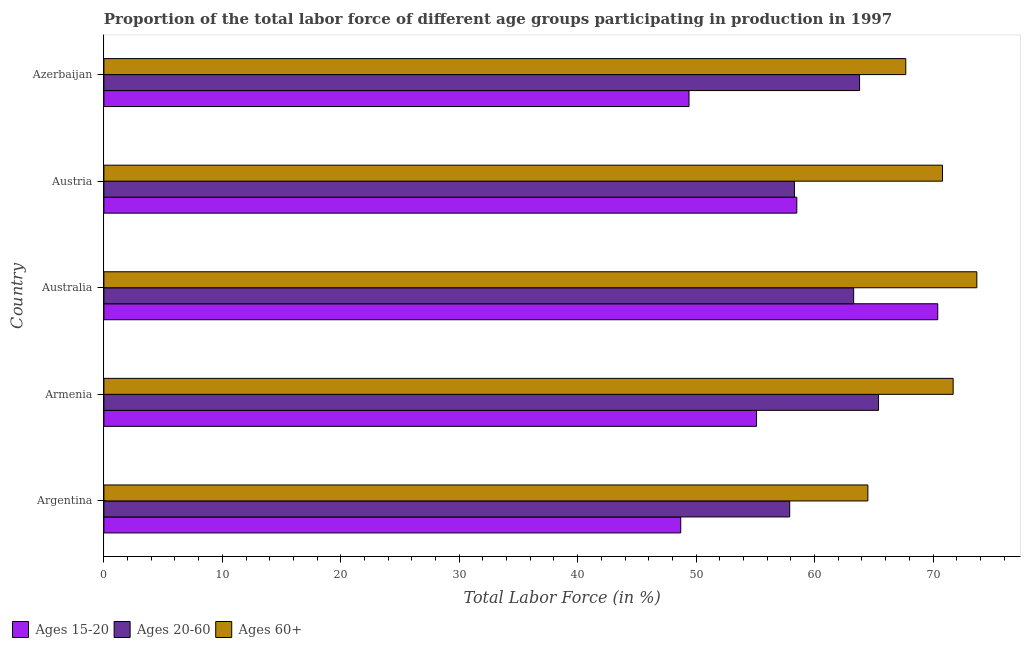How many different coloured bars are there?
Keep it short and to the point. 3. How many groups of bars are there?
Your answer should be compact. 5. Are the number of bars per tick equal to the number of legend labels?
Ensure brevity in your answer.  Yes. How many bars are there on the 1st tick from the bottom?
Ensure brevity in your answer.  3. What is the label of the 5th group of bars from the top?
Make the answer very short. Argentina. In how many cases, is the number of bars for a given country not equal to the number of legend labels?
Ensure brevity in your answer.  0. What is the percentage of labor force within the age group 20-60 in Australia?
Your answer should be compact. 63.3. Across all countries, what is the maximum percentage of labor force within the age group 15-20?
Your answer should be very brief. 70.4. Across all countries, what is the minimum percentage of labor force above age 60?
Keep it short and to the point. 64.5. What is the total percentage of labor force within the age group 20-60 in the graph?
Provide a succinct answer. 308.7. What is the difference between the percentage of labor force within the age group 20-60 in Armenia and that in Azerbaijan?
Make the answer very short. 1.6. What is the difference between the percentage of labor force above age 60 in Argentina and the percentage of labor force within the age group 20-60 in Azerbaijan?
Give a very brief answer. 0.7. What is the average percentage of labor force above age 60 per country?
Your answer should be very brief. 69.68. What is the difference between the percentage of labor force within the age group 15-20 and percentage of labor force above age 60 in Argentina?
Provide a short and direct response. -15.8. In how many countries, is the percentage of labor force within the age group 20-60 greater than 12 %?
Provide a short and direct response. 5. What is the ratio of the percentage of labor force above age 60 in Austria to that in Azerbaijan?
Offer a very short reply. 1.05. Is the difference between the percentage of labor force within the age group 20-60 in Austria and Azerbaijan greater than the difference between the percentage of labor force above age 60 in Austria and Azerbaijan?
Your answer should be very brief. No. What is the difference between the highest and the second highest percentage of labor force within the age group 15-20?
Offer a very short reply. 11.9. What is the difference between the highest and the lowest percentage of labor force within the age group 15-20?
Offer a very short reply. 21.7. What does the 3rd bar from the top in Austria represents?
Give a very brief answer. Ages 15-20. What does the 2nd bar from the bottom in Austria represents?
Your answer should be very brief. Ages 20-60. Is it the case that in every country, the sum of the percentage of labor force within the age group 15-20 and percentage of labor force within the age group 20-60 is greater than the percentage of labor force above age 60?
Your answer should be compact. Yes. What is the difference between two consecutive major ticks on the X-axis?
Ensure brevity in your answer.  10. Are the values on the major ticks of X-axis written in scientific E-notation?
Your response must be concise. No. Does the graph contain grids?
Offer a terse response. No. What is the title of the graph?
Provide a succinct answer. Proportion of the total labor force of different age groups participating in production in 1997. What is the label or title of the X-axis?
Provide a short and direct response. Total Labor Force (in %). What is the label or title of the Y-axis?
Offer a very short reply. Country. What is the Total Labor Force (in %) of Ages 15-20 in Argentina?
Provide a succinct answer. 48.7. What is the Total Labor Force (in %) in Ages 20-60 in Argentina?
Provide a succinct answer. 57.9. What is the Total Labor Force (in %) of Ages 60+ in Argentina?
Provide a succinct answer. 64.5. What is the Total Labor Force (in %) of Ages 15-20 in Armenia?
Make the answer very short. 55.1. What is the Total Labor Force (in %) in Ages 20-60 in Armenia?
Make the answer very short. 65.4. What is the Total Labor Force (in %) of Ages 60+ in Armenia?
Make the answer very short. 71.7. What is the Total Labor Force (in %) of Ages 15-20 in Australia?
Your answer should be compact. 70.4. What is the Total Labor Force (in %) of Ages 20-60 in Australia?
Ensure brevity in your answer.  63.3. What is the Total Labor Force (in %) in Ages 60+ in Australia?
Provide a short and direct response. 73.7. What is the Total Labor Force (in %) in Ages 15-20 in Austria?
Provide a short and direct response. 58.5. What is the Total Labor Force (in %) in Ages 20-60 in Austria?
Offer a terse response. 58.3. What is the Total Labor Force (in %) of Ages 60+ in Austria?
Your answer should be compact. 70.8. What is the Total Labor Force (in %) of Ages 15-20 in Azerbaijan?
Your answer should be very brief. 49.4. What is the Total Labor Force (in %) in Ages 20-60 in Azerbaijan?
Give a very brief answer. 63.8. What is the Total Labor Force (in %) in Ages 60+ in Azerbaijan?
Provide a succinct answer. 67.7. Across all countries, what is the maximum Total Labor Force (in %) in Ages 15-20?
Ensure brevity in your answer.  70.4. Across all countries, what is the maximum Total Labor Force (in %) of Ages 20-60?
Your response must be concise. 65.4. Across all countries, what is the maximum Total Labor Force (in %) in Ages 60+?
Keep it short and to the point. 73.7. Across all countries, what is the minimum Total Labor Force (in %) in Ages 15-20?
Ensure brevity in your answer.  48.7. Across all countries, what is the minimum Total Labor Force (in %) of Ages 20-60?
Offer a terse response. 57.9. Across all countries, what is the minimum Total Labor Force (in %) of Ages 60+?
Keep it short and to the point. 64.5. What is the total Total Labor Force (in %) of Ages 15-20 in the graph?
Your response must be concise. 282.1. What is the total Total Labor Force (in %) of Ages 20-60 in the graph?
Your answer should be compact. 308.7. What is the total Total Labor Force (in %) in Ages 60+ in the graph?
Ensure brevity in your answer.  348.4. What is the difference between the Total Labor Force (in %) of Ages 15-20 in Argentina and that in Armenia?
Keep it short and to the point. -6.4. What is the difference between the Total Labor Force (in %) of Ages 60+ in Argentina and that in Armenia?
Your response must be concise. -7.2. What is the difference between the Total Labor Force (in %) of Ages 15-20 in Argentina and that in Australia?
Ensure brevity in your answer.  -21.7. What is the difference between the Total Labor Force (in %) in Ages 20-60 in Argentina and that in Australia?
Give a very brief answer. -5.4. What is the difference between the Total Labor Force (in %) in Ages 60+ in Argentina and that in Australia?
Offer a terse response. -9.2. What is the difference between the Total Labor Force (in %) in Ages 15-20 in Argentina and that in Austria?
Offer a terse response. -9.8. What is the difference between the Total Labor Force (in %) in Ages 20-60 in Argentina and that in Austria?
Make the answer very short. -0.4. What is the difference between the Total Labor Force (in %) in Ages 15-20 in Argentina and that in Azerbaijan?
Offer a terse response. -0.7. What is the difference between the Total Labor Force (in %) of Ages 15-20 in Armenia and that in Australia?
Keep it short and to the point. -15.3. What is the difference between the Total Labor Force (in %) in Ages 20-60 in Armenia and that in Austria?
Offer a terse response. 7.1. What is the difference between the Total Labor Force (in %) of Ages 60+ in Armenia and that in Austria?
Provide a succinct answer. 0.9. What is the difference between the Total Labor Force (in %) in Ages 20-60 in Armenia and that in Azerbaijan?
Give a very brief answer. 1.6. What is the difference between the Total Labor Force (in %) of Ages 60+ in Armenia and that in Azerbaijan?
Keep it short and to the point. 4. What is the difference between the Total Labor Force (in %) of Ages 15-20 in Australia and that in Azerbaijan?
Your answer should be very brief. 21. What is the difference between the Total Labor Force (in %) of Ages 60+ in Australia and that in Azerbaijan?
Provide a short and direct response. 6. What is the difference between the Total Labor Force (in %) of Ages 20-60 in Austria and that in Azerbaijan?
Provide a short and direct response. -5.5. What is the difference between the Total Labor Force (in %) in Ages 15-20 in Argentina and the Total Labor Force (in %) in Ages 20-60 in Armenia?
Your answer should be compact. -16.7. What is the difference between the Total Labor Force (in %) in Ages 20-60 in Argentina and the Total Labor Force (in %) in Ages 60+ in Armenia?
Provide a succinct answer. -13.8. What is the difference between the Total Labor Force (in %) of Ages 15-20 in Argentina and the Total Labor Force (in %) of Ages 20-60 in Australia?
Make the answer very short. -14.6. What is the difference between the Total Labor Force (in %) in Ages 15-20 in Argentina and the Total Labor Force (in %) in Ages 60+ in Australia?
Keep it short and to the point. -25. What is the difference between the Total Labor Force (in %) in Ages 20-60 in Argentina and the Total Labor Force (in %) in Ages 60+ in Australia?
Your answer should be very brief. -15.8. What is the difference between the Total Labor Force (in %) of Ages 15-20 in Argentina and the Total Labor Force (in %) of Ages 60+ in Austria?
Your answer should be compact. -22.1. What is the difference between the Total Labor Force (in %) in Ages 20-60 in Argentina and the Total Labor Force (in %) in Ages 60+ in Austria?
Provide a succinct answer. -12.9. What is the difference between the Total Labor Force (in %) of Ages 15-20 in Argentina and the Total Labor Force (in %) of Ages 20-60 in Azerbaijan?
Provide a succinct answer. -15.1. What is the difference between the Total Labor Force (in %) in Ages 15-20 in Armenia and the Total Labor Force (in %) in Ages 20-60 in Australia?
Your response must be concise. -8.2. What is the difference between the Total Labor Force (in %) of Ages 15-20 in Armenia and the Total Labor Force (in %) of Ages 60+ in Australia?
Ensure brevity in your answer.  -18.6. What is the difference between the Total Labor Force (in %) of Ages 15-20 in Armenia and the Total Labor Force (in %) of Ages 60+ in Austria?
Ensure brevity in your answer.  -15.7. What is the difference between the Total Labor Force (in %) in Ages 15-20 in Armenia and the Total Labor Force (in %) in Ages 20-60 in Azerbaijan?
Keep it short and to the point. -8.7. What is the difference between the Total Labor Force (in %) of Ages 15-20 in Australia and the Total Labor Force (in %) of Ages 20-60 in Austria?
Make the answer very short. 12.1. What is the difference between the Total Labor Force (in %) of Ages 15-20 in Australia and the Total Labor Force (in %) of Ages 60+ in Austria?
Your answer should be very brief. -0.4. What is the difference between the Total Labor Force (in %) of Ages 15-20 in Australia and the Total Labor Force (in %) of Ages 20-60 in Azerbaijan?
Make the answer very short. 6.6. What is the difference between the Total Labor Force (in %) of Ages 15-20 in Australia and the Total Labor Force (in %) of Ages 60+ in Azerbaijan?
Your answer should be compact. 2.7. What is the difference between the Total Labor Force (in %) in Ages 20-60 in Australia and the Total Labor Force (in %) in Ages 60+ in Azerbaijan?
Provide a succinct answer. -4.4. What is the difference between the Total Labor Force (in %) of Ages 15-20 in Austria and the Total Labor Force (in %) of Ages 60+ in Azerbaijan?
Your answer should be compact. -9.2. What is the difference between the Total Labor Force (in %) of Ages 20-60 in Austria and the Total Labor Force (in %) of Ages 60+ in Azerbaijan?
Ensure brevity in your answer.  -9.4. What is the average Total Labor Force (in %) of Ages 15-20 per country?
Provide a short and direct response. 56.42. What is the average Total Labor Force (in %) of Ages 20-60 per country?
Your answer should be very brief. 61.74. What is the average Total Labor Force (in %) of Ages 60+ per country?
Offer a very short reply. 69.68. What is the difference between the Total Labor Force (in %) of Ages 15-20 and Total Labor Force (in %) of Ages 60+ in Argentina?
Keep it short and to the point. -15.8. What is the difference between the Total Labor Force (in %) of Ages 15-20 and Total Labor Force (in %) of Ages 60+ in Armenia?
Keep it short and to the point. -16.6. What is the difference between the Total Labor Force (in %) in Ages 20-60 and Total Labor Force (in %) in Ages 60+ in Armenia?
Make the answer very short. -6.3. What is the difference between the Total Labor Force (in %) in Ages 15-20 and Total Labor Force (in %) in Ages 20-60 in Australia?
Offer a terse response. 7.1. What is the difference between the Total Labor Force (in %) of Ages 20-60 and Total Labor Force (in %) of Ages 60+ in Australia?
Make the answer very short. -10.4. What is the difference between the Total Labor Force (in %) of Ages 15-20 and Total Labor Force (in %) of Ages 60+ in Austria?
Your response must be concise. -12.3. What is the difference between the Total Labor Force (in %) in Ages 15-20 and Total Labor Force (in %) in Ages 20-60 in Azerbaijan?
Provide a succinct answer. -14.4. What is the difference between the Total Labor Force (in %) of Ages 15-20 and Total Labor Force (in %) of Ages 60+ in Azerbaijan?
Your answer should be compact. -18.3. What is the difference between the Total Labor Force (in %) of Ages 20-60 and Total Labor Force (in %) of Ages 60+ in Azerbaijan?
Your answer should be compact. -3.9. What is the ratio of the Total Labor Force (in %) in Ages 15-20 in Argentina to that in Armenia?
Your answer should be compact. 0.88. What is the ratio of the Total Labor Force (in %) in Ages 20-60 in Argentina to that in Armenia?
Offer a terse response. 0.89. What is the ratio of the Total Labor Force (in %) of Ages 60+ in Argentina to that in Armenia?
Keep it short and to the point. 0.9. What is the ratio of the Total Labor Force (in %) of Ages 15-20 in Argentina to that in Australia?
Your answer should be very brief. 0.69. What is the ratio of the Total Labor Force (in %) in Ages 20-60 in Argentina to that in Australia?
Offer a very short reply. 0.91. What is the ratio of the Total Labor Force (in %) of Ages 60+ in Argentina to that in Australia?
Offer a terse response. 0.88. What is the ratio of the Total Labor Force (in %) of Ages 15-20 in Argentina to that in Austria?
Your response must be concise. 0.83. What is the ratio of the Total Labor Force (in %) in Ages 20-60 in Argentina to that in Austria?
Provide a short and direct response. 0.99. What is the ratio of the Total Labor Force (in %) of Ages 60+ in Argentina to that in Austria?
Keep it short and to the point. 0.91. What is the ratio of the Total Labor Force (in %) in Ages 15-20 in Argentina to that in Azerbaijan?
Offer a very short reply. 0.99. What is the ratio of the Total Labor Force (in %) in Ages 20-60 in Argentina to that in Azerbaijan?
Ensure brevity in your answer.  0.91. What is the ratio of the Total Labor Force (in %) in Ages 60+ in Argentina to that in Azerbaijan?
Make the answer very short. 0.95. What is the ratio of the Total Labor Force (in %) of Ages 15-20 in Armenia to that in Australia?
Provide a short and direct response. 0.78. What is the ratio of the Total Labor Force (in %) of Ages 20-60 in Armenia to that in Australia?
Provide a succinct answer. 1.03. What is the ratio of the Total Labor Force (in %) of Ages 60+ in Armenia to that in Australia?
Provide a short and direct response. 0.97. What is the ratio of the Total Labor Force (in %) in Ages 15-20 in Armenia to that in Austria?
Make the answer very short. 0.94. What is the ratio of the Total Labor Force (in %) in Ages 20-60 in Armenia to that in Austria?
Provide a succinct answer. 1.12. What is the ratio of the Total Labor Force (in %) in Ages 60+ in Armenia to that in Austria?
Your answer should be compact. 1.01. What is the ratio of the Total Labor Force (in %) of Ages 15-20 in Armenia to that in Azerbaijan?
Offer a very short reply. 1.12. What is the ratio of the Total Labor Force (in %) in Ages 20-60 in Armenia to that in Azerbaijan?
Keep it short and to the point. 1.03. What is the ratio of the Total Labor Force (in %) in Ages 60+ in Armenia to that in Azerbaijan?
Provide a short and direct response. 1.06. What is the ratio of the Total Labor Force (in %) of Ages 15-20 in Australia to that in Austria?
Your response must be concise. 1.2. What is the ratio of the Total Labor Force (in %) of Ages 20-60 in Australia to that in Austria?
Ensure brevity in your answer.  1.09. What is the ratio of the Total Labor Force (in %) of Ages 60+ in Australia to that in Austria?
Provide a succinct answer. 1.04. What is the ratio of the Total Labor Force (in %) in Ages 15-20 in Australia to that in Azerbaijan?
Offer a very short reply. 1.43. What is the ratio of the Total Labor Force (in %) of Ages 20-60 in Australia to that in Azerbaijan?
Provide a succinct answer. 0.99. What is the ratio of the Total Labor Force (in %) in Ages 60+ in Australia to that in Azerbaijan?
Provide a succinct answer. 1.09. What is the ratio of the Total Labor Force (in %) of Ages 15-20 in Austria to that in Azerbaijan?
Your answer should be compact. 1.18. What is the ratio of the Total Labor Force (in %) in Ages 20-60 in Austria to that in Azerbaijan?
Offer a very short reply. 0.91. What is the ratio of the Total Labor Force (in %) in Ages 60+ in Austria to that in Azerbaijan?
Make the answer very short. 1.05. What is the difference between the highest and the second highest Total Labor Force (in %) of Ages 15-20?
Provide a short and direct response. 11.9. What is the difference between the highest and the second highest Total Labor Force (in %) of Ages 60+?
Provide a short and direct response. 2. What is the difference between the highest and the lowest Total Labor Force (in %) in Ages 15-20?
Offer a terse response. 21.7. What is the difference between the highest and the lowest Total Labor Force (in %) in Ages 20-60?
Your answer should be compact. 7.5. 